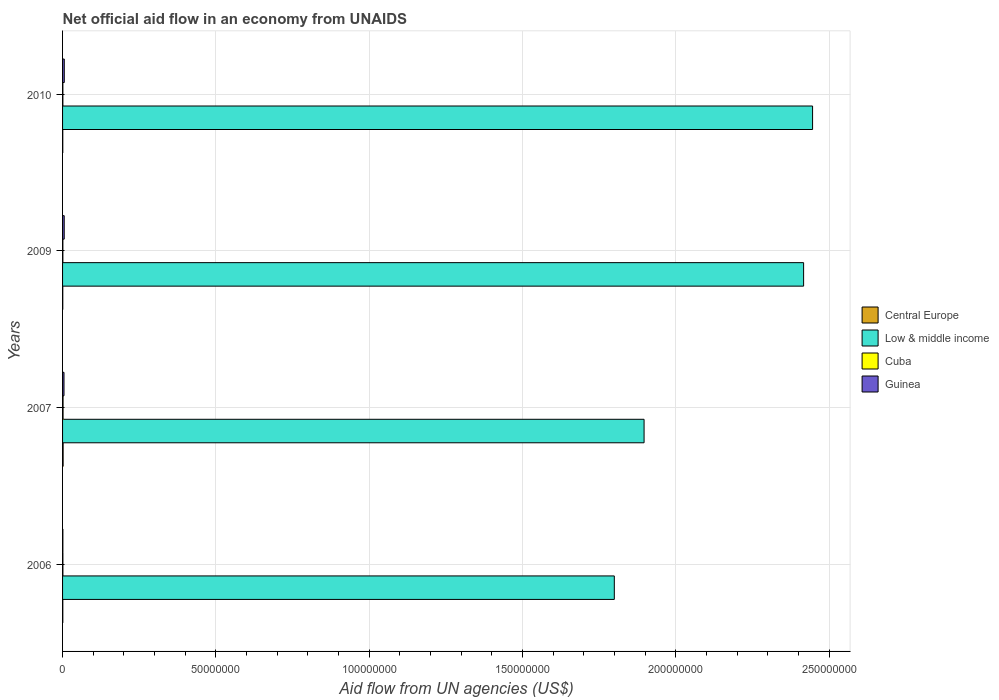How many bars are there on the 2nd tick from the top?
Offer a very short reply. 4. What is the label of the 2nd group of bars from the top?
Make the answer very short. 2009. In how many cases, is the number of bars for a given year not equal to the number of legend labels?
Offer a terse response. 0. What is the net official aid flow in Central Europe in 2010?
Offer a terse response. 7.00e+04. Across all years, what is the maximum net official aid flow in Guinea?
Ensure brevity in your answer.  5.60e+05. Across all years, what is the minimum net official aid flow in Central Europe?
Keep it short and to the point. 7.00e+04. In which year was the net official aid flow in Low & middle income minimum?
Give a very brief answer. 2006. What is the total net official aid flow in Low & middle income in the graph?
Make the answer very short. 8.56e+08. What is the difference between the net official aid flow in Cuba in 2009 and the net official aid flow in Guinea in 2007?
Give a very brief answer. -3.70e+05. What is the average net official aid flow in Cuba per year?
Keep it short and to the point. 1.18e+05. In the year 2006, what is the difference between the net official aid flow in Guinea and net official aid flow in Cuba?
Provide a succinct answer. -10000. In how many years, is the net official aid flow in Guinea greater than 240000000 US$?
Ensure brevity in your answer.  0. What is the ratio of the net official aid flow in Guinea in 2006 to that in 2010?
Keep it short and to the point. 0.18. What is the difference between the highest and the second highest net official aid flow in Central Europe?
Ensure brevity in your answer.  1.00e+05. What is the difference between the highest and the lowest net official aid flow in Cuba?
Offer a terse response. 6.00e+04. In how many years, is the net official aid flow in Central Europe greater than the average net official aid flow in Central Europe taken over all years?
Your answer should be very brief. 1. What does the 3rd bar from the top in 2006 represents?
Offer a very short reply. Low & middle income. What does the 4th bar from the bottom in 2009 represents?
Keep it short and to the point. Guinea. Is it the case that in every year, the sum of the net official aid flow in Cuba and net official aid flow in Central Europe is greater than the net official aid flow in Low & middle income?
Provide a short and direct response. No. Are all the bars in the graph horizontal?
Give a very brief answer. Yes. Are the values on the major ticks of X-axis written in scientific E-notation?
Keep it short and to the point. No. How are the legend labels stacked?
Ensure brevity in your answer.  Vertical. What is the title of the graph?
Provide a short and direct response. Net official aid flow in an economy from UNAIDS. What is the label or title of the X-axis?
Ensure brevity in your answer.  Aid flow from UN agencies (US$). What is the Aid flow from UN agencies (US$) of Low & middle income in 2006?
Make the answer very short. 1.80e+08. What is the Aid flow from UN agencies (US$) in Guinea in 2006?
Your answer should be compact. 1.00e+05. What is the Aid flow from UN agencies (US$) in Central Europe in 2007?
Offer a very short reply. 1.80e+05. What is the Aid flow from UN agencies (US$) in Low & middle income in 2007?
Provide a succinct answer. 1.90e+08. What is the Aid flow from UN agencies (US$) in Cuba in 2007?
Keep it short and to the point. 1.60e+05. What is the Aid flow from UN agencies (US$) of Low & middle income in 2009?
Offer a terse response. 2.42e+08. What is the Aid flow from UN agencies (US$) of Guinea in 2009?
Provide a short and direct response. 5.40e+05. What is the Aid flow from UN agencies (US$) of Low & middle income in 2010?
Ensure brevity in your answer.  2.45e+08. What is the Aid flow from UN agencies (US$) of Cuba in 2010?
Give a very brief answer. 1.00e+05. What is the Aid flow from UN agencies (US$) in Guinea in 2010?
Your answer should be compact. 5.60e+05. Across all years, what is the maximum Aid flow from UN agencies (US$) of Central Europe?
Your answer should be very brief. 1.80e+05. Across all years, what is the maximum Aid flow from UN agencies (US$) of Low & middle income?
Provide a short and direct response. 2.45e+08. Across all years, what is the maximum Aid flow from UN agencies (US$) in Cuba?
Offer a terse response. 1.60e+05. Across all years, what is the maximum Aid flow from UN agencies (US$) of Guinea?
Offer a terse response. 5.60e+05. Across all years, what is the minimum Aid flow from UN agencies (US$) in Central Europe?
Offer a very short reply. 7.00e+04. Across all years, what is the minimum Aid flow from UN agencies (US$) of Low & middle income?
Keep it short and to the point. 1.80e+08. Across all years, what is the minimum Aid flow from UN agencies (US$) of Cuba?
Your answer should be compact. 1.00e+05. Across all years, what is the minimum Aid flow from UN agencies (US$) of Guinea?
Offer a very short reply. 1.00e+05. What is the total Aid flow from UN agencies (US$) of Central Europe in the graph?
Ensure brevity in your answer.  4.00e+05. What is the total Aid flow from UN agencies (US$) of Low & middle income in the graph?
Offer a terse response. 8.56e+08. What is the total Aid flow from UN agencies (US$) in Cuba in the graph?
Make the answer very short. 4.70e+05. What is the total Aid flow from UN agencies (US$) in Guinea in the graph?
Keep it short and to the point. 1.67e+06. What is the difference between the Aid flow from UN agencies (US$) of Central Europe in 2006 and that in 2007?
Give a very brief answer. -1.00e+05. What is the difference between the Aid flow from UN agencies (US$) in Low & middle income in 2006 and that in 2007?
Your response must be concise. -9.71e+06. What is the difference between the Aid flow from UN agencies (US$) in Cuba in 2006 and that in 2007?
Give a very brief answer. -5.00e+04. What is the difference between the Aid flow from UN agencies (US$) of Guinea in 2006 and that in 2007?
Offer a very short reply. -3.70e+05. What is the difference between the Aid flow from UN agencies (US$) in Low & middle income in 2006 and that in 2009?
Ensure brevity in your answer.  -6.17e+07. What is the difference between the Aid flow from UN agencies (US$) of Cuba in 2006 and that in 2009?
Offer a very short reply. 10000. What is the difference between the Aid flow from UN agencies (US$) of Guinea in 2006 and that in 2009?
Your answer should be compact. -4.40e+05. What is the difference between the Aid flow from UN agencies (US$) in Central Europe in 2006 and that in 2010?
Offer a terse response. 10000. What is the difference between the Aid flow from UN agencies (US$) in Low & middle income in 2006 and that in 2010?
Give a very brief answer. -6.47e+07. What is the difference between the Aid flow from UN agencies (US$) of Guinea in 2006 and that in 2010?
Your answer should be compact. -4.60e+05. What is the difference between the Aid flow from UN agencies (US$) of Central Europe in 2007 and that in 2009?
Your response must be concise. 1.10e+05. What is the difference between the Aid flow from UN agencies (US$) of Low & middle income in 2007 and that in 2009?
Your answer should be very brief. -5.20e+07. What is the difference between the Aid flow from UN agencies (US$) in Guinea in 2007 and that in 2009?
Your answer should be compact. -7.00e+04. What is the difference between the Aid flow from UN agencies (US$) of Central Europe in 2007 and that in 2010?
Offer a terse response. 1.10e+05. What is the difference between the Aid flow from UN agencies (US$) of Low & middle income in 2007 and that in 2010?
Offer a terse response. -5.50e+07. What is the difference between the Aid flow from UN agencies (US$) of Cuba in 2007 and that in 2010?
Keep it short and to the point. 6.00e+04. What is the difference between the Aid flow from UN agencies (US$) in Guinea in 2007 and that in 2010?
Your answer should be compact. -9.00e+04. What is the difference between the Aid flow from UN agencies (US$) in Low & middle income in 2009 and that in 2010?
Give a very brief answer. -2.93e+06. What is the difference between the Aid flow from UN agencies (US$) in Cuba in 2009 and that in 2010?
Your response must be concise. 0. What is the difference between the Aid flow from UN agencies (US$) in Central Europe in 2006 and the Aid flow from UN agencies (US$) in Low & middle income in 2007?
Your answer should be very brief. -1.90e+08. What is the difference between the Aid flow from UN agencies (US$) of Central Europe in 2006 and the Aid flow from UN agencies (US$) of Cuba in 2007?
Provide a short and direct response. -8.00e+04. What is the difference between the Aid flow from UN agencies (US$) of Central Europe in 2006 and the Aid flow from UN agencies (US$) of Guinea in 2007?
Make the answer very short. -3.90e+05. What is the difference between the Aid flow from UN agencies (US$) of Low & middle income in 2006 and the Aid flow from UN agencies (US$) of Cuba in 2007?
Offer a terse response. 1.80e+08. What is the difference between the Aid flow from UN agencies (US$) of Low & middle income in 2006 and the Aid flow from UN agencies (US$) of Guinea in 2007?
Provide a succinct answer. 1.79e+08. What is the difference between the Aid flow from UN agencies (US$) of Cuba in 2006 and the Aid flow from UN agencies (US$) of Guinea in 2007?
Offer a terse response. -3.60e+05. What is the difference between the Aid flow from UN agencies (US$) in Central Europe in 2006 and the Aid flow from UN agencies (US$) in Low & middle income in 2009?
Offer a very short reply. -2.42e+08. What is the difference between the Aid flow from UN agencies (US$) in Central Europe in 2006 and the Aid flow from UN agencies (US$) in Guinea in 2009?
Offer a terse response. -4.60e+05. What is the difference between the Aid flow from UN agencies (US$) in Low & middle income in 2006 and the Aid flow from UN agencies (US$) in Cuba in 2009?
Offer a very short reply. 1.80e+08. What is the difference between the Aid flow from UN agencies (US$) in Low & middle income in 2006 and the Aid flow from UN agencies (US$) in Guinea in 2009?
Provide a short and direct response. 1.79e+08. What is the difference between the Aid flow from UN agencies (US$) of Cuba in 2006 and the Aid flow from UN agencies (US$) of Guinea in 2009?
Your answer should be compact. -4.30e+05. What is the difference between the Aid flow from UN agencies (US$) in Central Europe in 2006 and the Aid flow from UN agencies (US$) in Low & middle income in 2010?
Make the answer very short. -2.45e+08. What is the difference between the Aid flow from UN agencies (US$) in Central Europe in 2006 and the Aid flow from UN agencies (US$) in Guinea in 2010?
Your response must be concise. -4.80e+05. What is the difference between the Aid flow from UN agencies (US$) of Low & middle income in 2006 and the Aid flow from UN agencies (US$) of Cuba in 2010?
Keep it short and to the point. 1.80e+08. What is the difference between the Aid flow from UN agencies (US$) in Low & middle income in 2006 and the Aid flow from UN agencies (US$) in Guinea in 2010?
Offer a terse response. 1.79e+08. What is the difference between the Aid flow from UN agencies (US$) of Cuba in 2006 and the Aid flow from UN agencies (US$) of Guinea in 2010?
Give a very brief answer. -4.50e+05. What is the difference between the Aid flow from UN agencies (US$) of Central Europe in 2007 and the Aid flow from UN agencies (US$) of Low & middle income in 2009?
Keep it short and to the point. -2.42e+08. What is the difference between the Aid flow from UN agencies (US$) in Central Europe in 2007 and the Aid flow from UN agencies (US$) in Guinea in 2009?
Offer a terse response. -3.60e+05. What is the difference between the Aid flow from UN agencies (US$) in Low & middle income in 2007 and the Aid flow from UN agencies (US$) in Cuba in 2009?
Keep it short and to the point. 1.90e+08. What is the difference between the Aid flow from UN agencies (US$) of Low & middle income in 2007 and the Aid flow from UN agencies (US$) of Guinea in 2009?
Your response must be concise. 1.89e+08. What is the difference between the Aid flow from UN agencies (US$) of Cuba in 2007 and the Aid flow from UN agencies (US$) of Guinea in 2009?
Provide a short and direct response. -3.80e+05. What is the difference between the Aid flow from UN agencies (US$) of Central Europe in 2007 and the Aid flow from UN agencies (US$) of Low & middle income in 2010?
Your answer should be compact. -2.44e+08. What is the difference between the Aid flow from UN agencies (US$) of Central Europe in 2007 and the Aid flow from UN agencies (US$) of Cuba in 2010?
Offer a very short reply. 8.00e+04. What is the difference between the Aid flow from UN agencies (US$) in Central Europe in 2007 and the Aid flow from UN agencies (US$) in Guinea in 2010?
Keep it short and to the point. -3.80e+05. What is the difference between the Aid flow from UN agencies (US$) of Low & middle income in 2007 and the Aid flow from UN agencies (US$) of Cuba in 2010?
Offer a very short reply. 1.90e+08. What is the difference between the Aid flow from UN agencies (US$) of Low & middle income in 2007 and the Aid flow from UN agencies (US$) of Guinea in 2010?
Provide a succinct answer. 1.89e+08. What is the difference between the Aid flow from UN agencies (US$) in Cuba in 2007 and the Aid flow from UN agencies (US$) in Guinea in 2010?
Offer a very short reply. -4.00e+05. What is the difference between the Aid flow from UN agencies (US$) of Central Europe in 2009 and the Aid flow from UN agencies (US$) of Low & middle income in 2010?
Ensure brevity in your answer.  -2.45e+08. What is the difference between the Aid flow from UN agencies (US$) in Central Europe in 2009 and the Aid flow from UN agencies (US$) in Cuba in 2010?
Provide a short and direct response. -3.00e+04. What is the difference between the Aid flow from UN agencies (US$) of Central Europe in 2009 and the Aid flow from UN agencies (US$) of Guinea in 2010?
Keep it short and to the point. -4.90e+05. What is the difference between the Aid flow from UN agencies (US$) in Low & middle income in 2009 and the Aid flow from UN agencies (US$) in Cuba in 2010?
Offer a very short reply. 2.42e+08. What is the difference between the Aid flow from UN agencies (US$) in Low & middle income in 2009 and the Aid flow from UN agencies (US$) in Guinea in 2010?
Give a very brief answer. 2.41e+08. What is the difference between the Aid flow from UN agencies (US$) of Cuba in 2009 and the Aid flow from UN agencies (US$) of Guinea in 2010?
Give a very brief answer. -4.60e+05. What is the average Aid flow from UN agencies (US$) of Low & middle income per year?
Make the answer very short. 2.14e+08. What is the average Aid flow from UN agencies (US$) in Cuba per year?
Provide a succinct answer. 1.18e+05. What is the average Aid flow from UN agencies (US$) of Guinea per year?
Keep it short and to the point. 4.18e+05. In the year 2006, what is the difference between the Aid flow from UN agencies (US$) in Central Europe and Aid flow from UN agencies (US$) in Low & middle income?
Your response must be concise. -1.80e+08. In the year 2006, what is the difference between the Aid flow from UN agencies (US$) in Central Europe and Aid flow from UN agencies (US$) in Guinea?
Ensure brevity in your answer.  -2.00e+04. In the year 2006, what is the difference between the Aid flow from UN agencies (US$) of Low & middle income and Aid flow from UN agencies (US$) of Cuba?
Offer a very short reply. 1.80e+08. In the year 2006, what is the difference between the Aid flow from UN agencies (US$) of Low & middle income and Aid flow from UN agencies (US$) of Guinea?
Keep it short and to the point. 1.80e+08. In the year 2007, what is the difference between the Aid flow from UN agencies (US$) of Central Europe and Aid flow from UN agencies (US$) of Low & middle income?
Ensure brevity in your answer.  -1.89e+08. In the year 2007, what is the difference between the Aid flow from UN agencies (US$) of Central Europe and Aid flow from UN agencies (US$) of Cuba?
Ensure brevity in your answer.  2.00e+04. In the year 2007, what is the difference between the Aid flow from UN agencies (US$) in Low & middle income and Aid flow from UN agencies (US$) in Cuba?
Offer a terse response. 1.90e+08. In the year 2007, what is the difference between the Aid flow from UN agencies (US$) of Low & middle income and Aid flow from UN agencies (US$) of Guinea?
Your answer should be very brief. 1.89e+08. In the year 2007, what is the difference between the Aid flow from UN agencies (US$) in Cuba and Aid flow from UN agencies (US$) in Guinea?
Your response must be concise. -3.10e+05. In the year 2009, what is the difference between the Aid flow from UN agencies (US$) of Central Europe and Aid flow from UN agencies (US$) of Low & middle income?
Offer a terse response. -2.42e+08. In the year 2009, what is the difference between the Aid flow from UN agencies (US$) in Central Europe and Aid flow from UN agencies (US$) in Cuba?
Your response must be concise. -3.00e+04. In the year 2009, what is the difference between the Aid flow from UN agencies (US$) in Central Europe and Aid flow from UN agencies (US$) in Guinea?
Your answer should be very brief. -4.70e+05. In the year 2009, what is the difference between the Aid flow from UN agencies (US$) in Low & middle income and Aid flow from UN agencies (US$) in Cuba?
Provide a short and direct response. 2.42e+08. In the year 2009, what is the difference between the Aid flow from UN agencies (US$) in Low & middle income and Aid flow from UN agencies (US$) in Guinea?
Make the answer very short. 2.41e+08. In the year 2009, what is the difference between the Aid flow from UN agencies (US$) of Cuba and Aid flow from UN agencies (US$) of Guinea?
Offer a very short reply. -4.40e+05. In the year 2010, what is the difference between the Aid flow from UN agencies (US$) in Central Europe and Aid flow from UN agencies (US$) in Low & middle income?
Offer a very short reply. -2.45e+08. In the year 2010, what is the difference between the Aid flow from UN agencies (US$) in Central Europe and Aid flow from UN agencies (US$) in Cuba?
Your answer should be compact. -3.00e+04. In the year 2010, what is the difference between the Aid flow from UN agencies (US$) of Central Europe and Aid flow from UN agencies (US$) of Guinea?
Keep it short and to the point. -4.90e+05. In the year 2010, what is the difference between the Aid flow from UN agencies (US$) in Low & middle income and Aid flow from UN agencies (US$) in Cuba?
Your response must be concise. 2.45e+08. In the year 2010, what is the difference between the Aid flow from UN agencies (US$) in Low & middle income and Aid flow from UN agencies (US$) in Guinea?
Provide a short and direct response. 2.44e+08. In the year 2010, what is the difference between the Aid flow from UN agencies (US$) of Cuba and Aid flow from UN agencies (US$) of Guinea?
Keep it short and to the point. -4.60e+05. What is the ratio of the Aid flow from UN agencies (US$) of Central Europe in 2006 to that in 2007?
Your answer should be very brief. 0.44. What is the ratio of the Aid flow from UN agencies (US$) in Low & middle income in 2006 to that in 2007?
Your answer should be very brief. 0.95. What is the ratio of the Aid flow from UN agencies (US$) of Cuba in 2006 to that in 2007?
Offer a very short reply. 0.69. What is the ratio of the Aid flow from UN agencies (US$) in Guinea in 2006 to that in 2007?
Ensure brevity in your answer.  0.21. What is the ratio of the Aid flow from UN agencies (US$) in Central Europe in 2006 to that in 2009?
Your response must be concise. 1.14. What is the ratio of the Aid flow from UN agencies (US$) in Low & middle income in 2006 to that in 2009?
Ensure brevity in your answer.  0.74. What is the ratio of the Aid flow from UN agencies (US$) of Guinea in 2006 to that in 2009?
Give a very brief answer. 0.19. What is the ratio of the Aid flow from UN agencies (US$) in Low & middle income in 2006 to that in 2010?
Provide a short and direct response. 0.74. What is the ratio of the Aid flow from UN agencies (US$) of Cuba in 2006 to that in 2010?
Keep it short and to the point. 1.1. What is the ratio of the Aid flow from UN agencies (US$) of Guinea in 2006 to that in 2010?
Ensure brevity in your answer.  0.18. What is the ratio of the Aid flow from UN agencies (US$) of Central Europe in 2007 to that in 2009?
Give a very brief answer. 2.57. What is the ratio of the Aid flow from UN agencies (US$) of Low & middle income in 2007 to that in 2009?
Your answer should be compact. 0.78. What is the ratio of the Aid flow from UN agencies (US$) in Guinea in 2007 to that in 2009?
Ensure brevity in your answer.  0.87. What is the ratio of the Aid flow from UN agencies (US$) of Central Europe in 2007 to that in 2010?
Your answer should be compact. 2.57. What is the ratio of the Aid flow from UN agencies (US$) of Low & middle income in 2007 to that in 2010?
Keep it short and to the point. 0.78. What is the ratio of the Aid flow from UN agencies (US$) in Guinea in 2007 to that in 2010?
Provide a succinct answer. 0.84. What is the ratio of the Aid flow from UN agencies (US$) in Low & middle income in 2009 to that in 2010?
Ensure brevity in your answer.  0.99. What is the ratio of the Aid flow from UN agencies (US$) in Cuba in 2009 to that in 2010?
Provide a succinct answer. 1. What is the difference between the highest and the second highest Aid flow from UN agencies (US$) of Low & middle income?
Your response must be concise. 2.93e+06. What is the difference between the highest and the second highest Aid flow from UN agencies (US$) in Cuba?
Offer a terse response. 5.00e+04. What is the difference between the highest and the second highest Aid flow from UN agencies (US$) in Guinea?
Your answer should be very brief. 2.00e+04. What is the difference between the highest and the lowest Aid flow from UN agencies (US$) in Central Europe?
Offer a very short reply. 1.10e+05. What is the difference between the highest and the lowest Aid flow from UN agencies (US$) of Low & middle income?
Offer a very short reply. 6.47e+07. What is the difference between the highest and the lowest Aid flow from UN agencies (US$) in Cuba?
Give a very brief answer. 6.00e+04. 